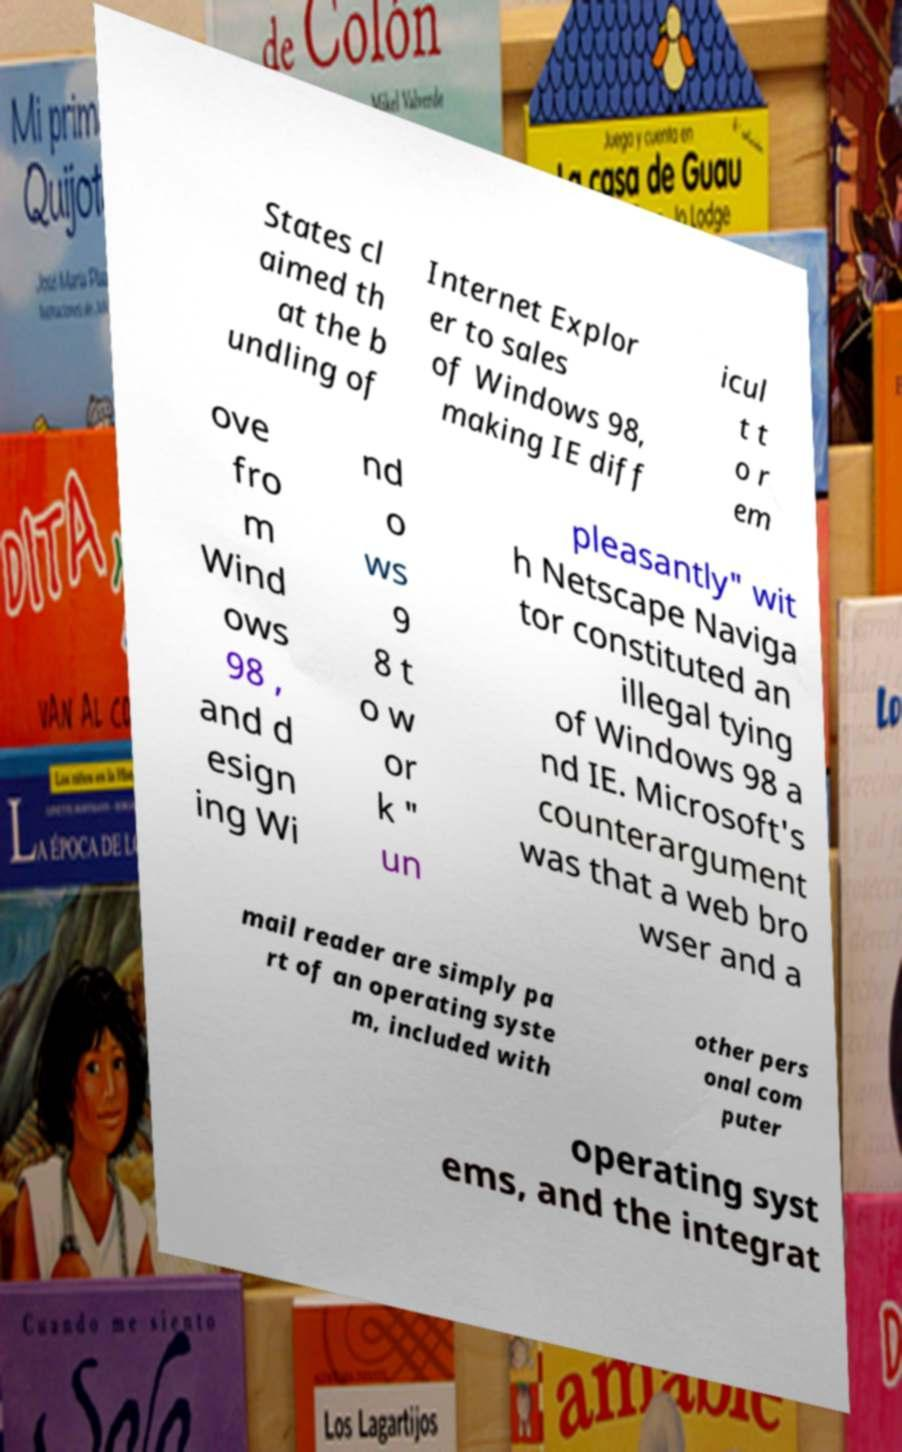Please identify and transcribe the text found in this image. States cl aimed th at the b undling of Internet Explor er to sales of Windows 98, making IE diff icul t t o r em ove fro m Wind ows 98 , and d esign ing Wi nd o ws 9 8 t o w or k " un pleasantly" wit h Netscape Naviga tor constituted an illegal tying of Windows 98 a nd IE. Microsoft's counterargument was that a web bro wser and a mail reader are simply pa rt of an operating syste m, included with other pers onal com puter operating syst ems, and the integrat 